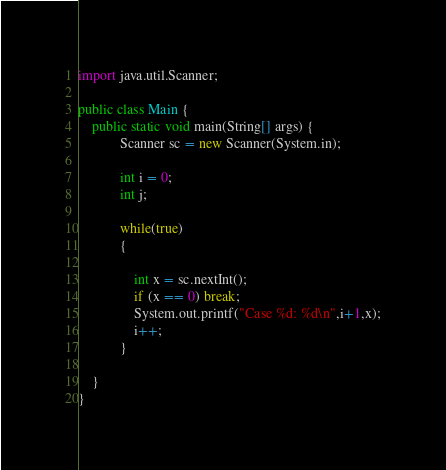Convert code to text. <code><loc_0><loc_0><loc_500><loc_500><_Java_>import java.util.Scanner;

public class Main {
	public static void main(String[] args) {
			Scanner sc = new Scanner(System.in); 

			int i = 0;
			int j;

			while(true)
			{
				
				int x = sc.nextInt();
				if (x == 0) break;
				System.out.printf("Case %d: %d\n",i+1,x);
				i++;
			}

	}
}</code> 